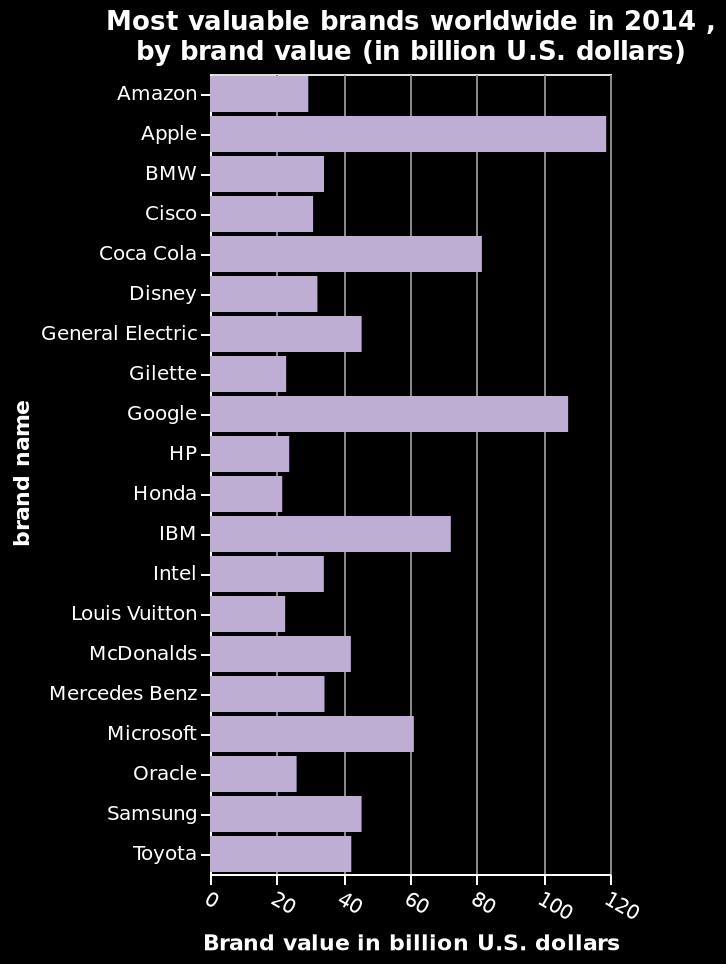<image>
What was the valuation of Apple, the most valuable brand in 2014?  Just under $120 billion. please enumerates aspects of the construction of the chart Here a is a bar plot titled Most valuable brands worldwide in 2014 , by brand value (in billion U.S. dollars). The y-axis plots brand name as categorical scale with Amazon on one end and Toyota at the other while the x-axis measures Brand value in billion U.S. dollars with linear scale with a minimum of 0 and a maximum of 120. What is the minimum valuation for all the most valuable brands listed?  $20 billion. please summary the statistics and relations of the chart Apple is with the most money. Honda is the smallest in value. Technology is the biggest earner. Is the y-axis in the bar plot titled Least valuable brands worldwide in 2014, by brand value (in million U.S. dollars) a numerical scale with Amazon on one end and Toyota at the other? No.Here a is a bar plot titled Most valuable brands worldwide in 2014 , by brand value (in billion U.S. dollars). The y-axis plots brand name as categorical scale with Amazon on one end and Toyota at the other while the x-axis measures Brand value in billion U.S. dollars with linear scale with a minimum of 0 and a maximum of 120. 